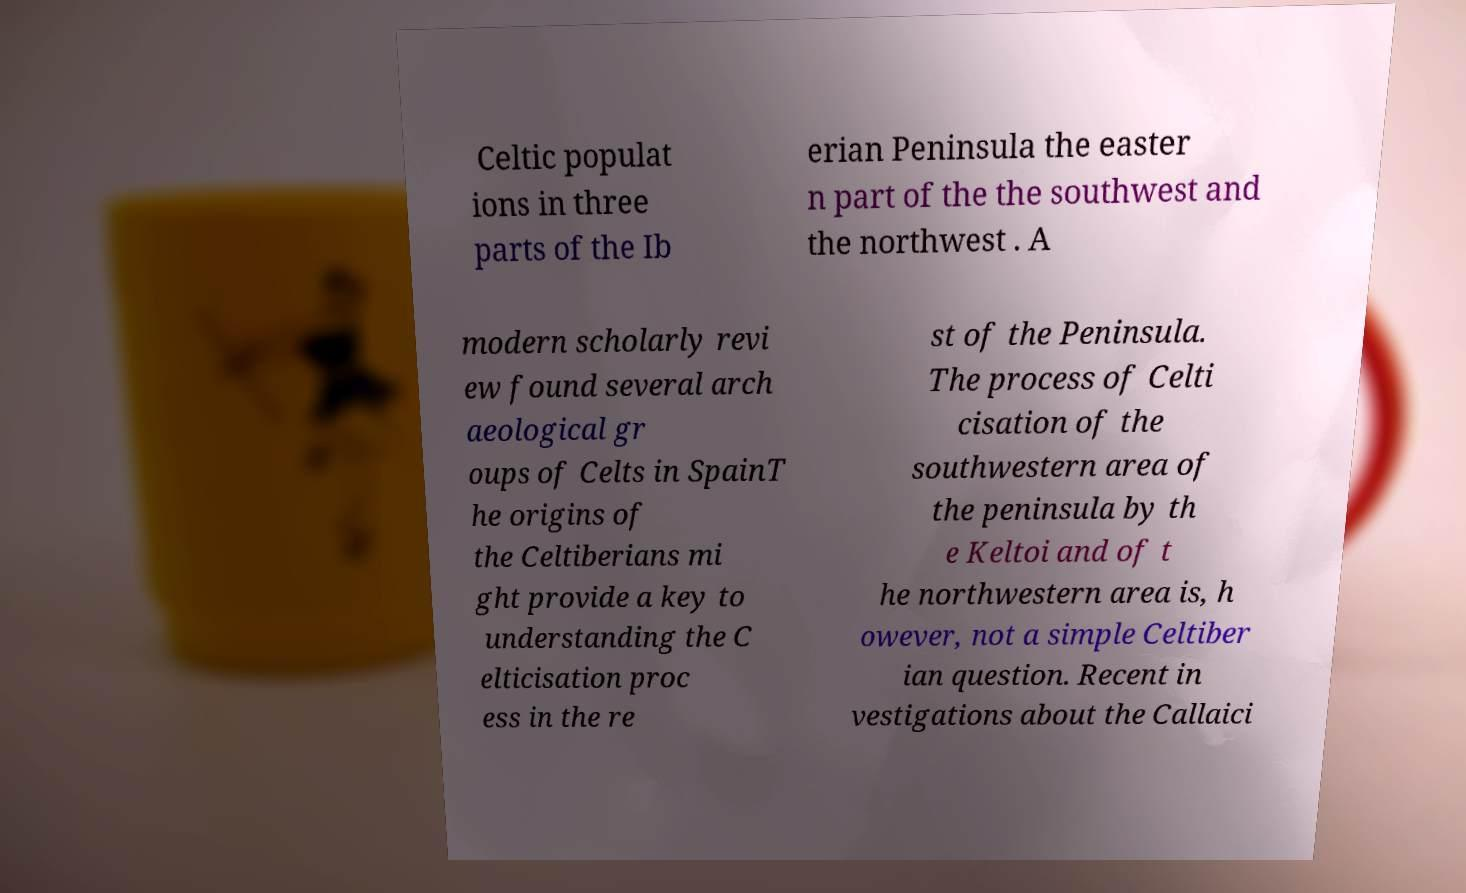What messages or text are displayed in this image? I need them in a readable, typed format. Celtic populat ions in three parts of the Ib erian Peninsula the easter n part of the the southwest and the northwest . A modern scholarly revi ew found several arch aeological gr oups of Celts in SpainT he origins of the Celtiberians mi ght provide a key to understanding the C elticisation proc ess in the re st of the Peninsula. The process of Celti cisation of the southwestern area of the peninsula by th e Keltoi and of t he northwestern area is, h owever, not a simple Celtiber ian question. Recent in vestigations about the Callaici 